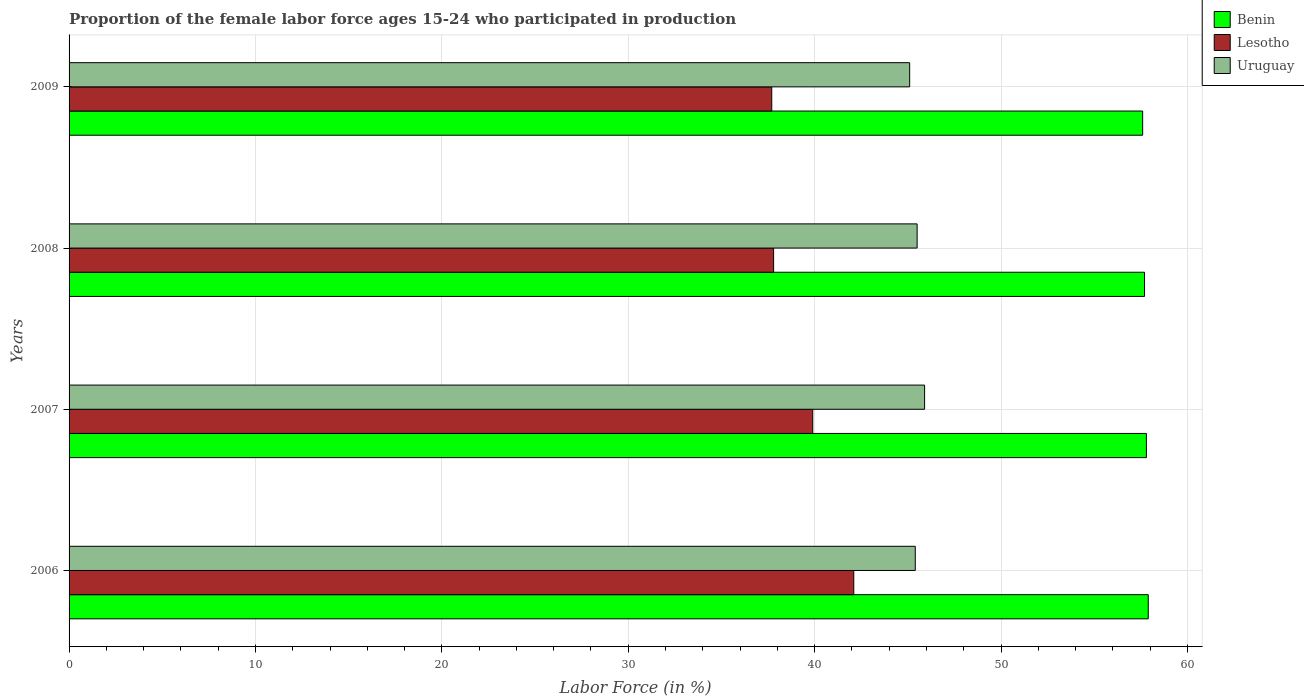How many different coloured bars are there?
Give a very brief answer. 3. How many groups of bars are there?
Ensure brevity in your answer.  4. Are the number of bars on each tick of the Y-axis equal?
Make the answer very short. Yes. What is the label of the 1st group of bars from the top?
Offer a terse response. 2009. In how many cases, is the number of bars for a given year not equal to the number of legend labels?
Offer a very short reply. 0. What is the proportion of the female labor force who participated in production in Uruguay in 2006?
Offer a very short reply. 45.4. Across all years, what is the maximum proportion of the female labor force who participated in production in Benin?
Your answer should be very brief. 57.9. Across all years, what is the minimum proportion of the female labor force who participated in production in Benin?
Ensure brevity in your answer.  57.6. In which year was the proportion of the female labor force who participated in production in Lesotho minimum?
Your answer should be compact. 2009. What is the total proportion of the female labor force who participated in production in Lesotho in the graph?
Offer a terse response. 157.5. What is the difference between the proportion of the female labor force who participated in production in Uruguay in 2006 and that in 2008?
Offer a terse response. -0.1. What is the difference between the proportion of the female labor force who participated in production in Lesotho in 2006 and the proportion of the female labor force who participated in production in Benin in 2007?
Offer a terse response. -15.7. What is the average proportion of the female labor force who participated in production in Lesotho per year?
Offer a terse response. 39.38. In the year 2007, what is the difference between the proportion of the female labor force who participated in production in Benin and proportion of the female labor force who participated in production in Uruguay?
Ensure brevity in your answer.  11.9. What is the ratio of the proportion of the female labor force who participated in production in Uruguay in 2007 to that in 2008?
Make the answer very short. 1.01. What is the difference between the highest and the second highest proportion of the female labor force who participated in production in Uruguay?
Give a very brief answer. 0.4. What is the difference between the highest and the lowest proportion of the female labor force who participated in production in Benin?
Ensure brevity in your answer.  0.3. Is the sum of the proportion of the female labor force who participated in production in Lesotho in 2006 and 2007 greater than the maximum proportion of the female labor force who participated in production in Benin across all years?
Provide a succinct answer. Yes. What does the 1st bar from the top in 2006 represents?
Offer a terse response. Uruguay. What does the 1st bar from the bottom in 2007 represents?
Ensure brevity in your answer.  Benin. How many bars are there?
Keep it short and to the point. 12. How many years are there in the graph?
Make the answer very short. 4. What is the difference between two consecutive major ticks on the X-axis?
Offer a very short reply. 10. Are the values on the major ticks of X-axis written in scientific E-notation?
Your answer should be very brief. No. Does the graph contain any zero values?
Your response must be concise. No. Does the graph contain grids?
Your answer should be very brief. Yes. Where does the legend appear in the graph?
Your answer should be compact. Top right. How many legend labels are there?
Provide a succinct answer. 3. What is the title of the graph?
Provide a succinct answer. Proportion of the female labor force ages 15-24 who participated in production. What is the label or title of the X-axis?
Give a very brief answer. Labor Force (in %). What is the label or title of the Y-axis?
Provide a short and direct response. Years. What is the Labor Force (in %) of Benin in 2006?
Provide a succinct answer. 57.9. What is the Labor Force (in %) of Lesotho in 2006?
Provide a succinct answer. 42.1. What is the Labor Force (in %) of Uruguay in 2006?
Your answer should be very brief. 45.4. What is the Labor Force (in %) of Benin in 2007?
Offer a terse response. 57.8. What is the Labor Force (in %) of Lesotho in 2007?
Keep it short and to the point. 39.9. What is the Labor Force (in %) in Uruguay in 2007?
Your response must be concise. 45.9. What is the Labor Force (in %) in Benin in 2008?
Keep it short and to the point. 57.7. What is the Labor Force (in %) in Lesotho in 2008?
Offer a very short reply. 37.8. What is the Labor Force (in %) of Uruguay in 2008?
Offer a terse response. 45.5. What is the Labor Force (in %) of Benin in 2009?
Your answer should be very brief. 57.6. What is the Labor Force (in %) in Lesotho in 2009?
Provide a short and direct response. 37.7. What is the Labor Force (in %) in Uruguay in 2009?
Provide a short and direct response. 45.1. Across all years, what is the maximum Labor Force (in %) of Benin?
Make the answer very short. 57.9. Across all years, what is the maximum Labor Force (in %) in Lesotho?
Your response must be concise. 42.1. Across all years, what is the maximum Labor Force (in %) of Uruguay?
Provide a short and direct response. 45.9. Across all years, what is the minimum Labor Force (in %) in Benin?
Your answer should be compact. 57.6. Across all years, what is the minimum Labor Force (in %) of Lesotho?
Ensure brevity in your answer.  37.7. Across all years, what is the minimum Labor Force (in %) in Uruguay?
Make the answer very short. 45.1. What is the total Labor Force (in %) in Benin in the graph?
Your answer should be very brief. 231. What is the total Labor Force (in %) in Lesotho in the graph?
Offer a terse response. 157.5. What is the total Labor Force (in %) of Uruguay in the graph?
Your answer should be very brief. 181.9. What is the difference between the Labor Force (in %) in Benin in 2006 and that in 2007?
Keep it short and to the point. 0.1. What is the difference between the Labor Force (in %) of Lesotho in 2006 and that in 2008?
Your answer should be compact. 4.3. What is the difference between the Labor Force (in %) in Uruguay in 2006 and that in 2008?
Keep it short and to the point. -0.1. What is the difference between the Labor Force (in %) of Benin in 2006 and that in 2009?
Provide a short and direct response. 0.3. What is the difference between the Labor Force (in %) of Benin in 2007 and that in 2008?
Provide a short and direct response. 0.1. What is the difference between the Labor Force (in %) of Uruguay in 2007 and that in 2008?
Your response must be concise. 0.4. What is the difference between the Labor Force (in %) of Benin in 2007 and that in 2009?
Offer a very short reply. 0.2. What is the difference between the Labor Force (in %) of Lesotho in 2007 and that in 2009?
Offer a terse response. 2.2. What is the difference between the Labor Force (in %) of Uruguay in 2007 and that in 2009?
Ensure brevity in your answer.  0.8. What is the difference between the Labor Force (in %) of Benin in 2008 and that in 2009?
Give a very brief answer. 0.1. What is the difference between the Labor Force (in %) in Benin in 2006 and the Labor Force (in %) in Lesotho in 2007?
Offer a terse response. 18. What is the difference between the Labor Force (in %) in Benin in 2006 and the Labor Force (in %) in Uruguay in 2007?
Your answer should be very brief. 12. What is the difference between the Labor Force (in %) in Lesotho in 2006 and the Labor Force (in %) in Uruguay in 2007?
Provide a succinct answer. -3.8. What is the difference between the Labor Force (in %) in Benin in 2006 and the Labor Force (in %) in Lesotho in 2008?
Offer a terse response. 20.1. What is the difference between the Labor Force (in %) in Benin in 2006 and the Labor Force (in %) in Uruguay in 2008?
Make the answer very short. 12.4. What is the difference between the Labor Force (in %) of Benin in 2006 and the Labor Force (in %) of Lesotho in 2009?
Provide a succinct answer. 20.2. What is the difference between the Labor Force (in %) of Benin in 2007 and the Labor Force (in %) of Lesotho in 2008?
Provide a short and direct response. 20. What is the difference between the Labor Force (in %) in Benin in 2007 and the Labor Force (in %) in Lesotho in 2009?
Your response must be concise. 20.1. What is the average Labor Force (in %) in Benin per year?
Make the answer very short. 57.75. What is the average Labor Force (in %) of Lesotho per year?
Provide a succinct answer. 39.38. What is the average Labor Force (in %) of Uruguay per year?
Your response must be concise. 45.48. In the year 2006, what is the difference between the Labor Force (in %) of Benin and Labor Force (in %) of Lesotho?
Give a very brief answer. 15.8. In the year 2007, what is the difference between the Labor Force (in %) in Benin and Labor Force (in %) in Lesotho?
Ensure brevity in your answer.  17.9. In the year 2007, what is the difference between the Labor Force (in %) in Benin and Labor Force (in %) in Uruguay?
Ensure brevity in your answer.  11.9. In the year 2008, what is the difference between the Labor Force (in %) of Benin and Labor Force (in %) of Uruguay?
Offer a very short reply. 12.2. In the year 2008, what is the difference between the Labor Force (in %) of Lesotho and Labor Force (in %) of Uruguay?
Offer a very short reply. -7.7. In the year 2009, what is the difference between the Labor Force (in %) of Benin and Labor Force (in %) of Lesotho?
Offer a terse response. 19.9. In the year 2009, what is the difference between the Labor Force (in %) of Benin and Labor Force (in %) of Uruguay?
Offer a very short reply. 12.5. In the year 2009, what is the difference between the Labor Force (in %) of Lesotho and Labor Force (in %) of Uruguay?
Keep it short and to the point. -7.4. What is the ratio of the Labor Force (in %) in Lesotho in 2006 to that in 2007?
Keep it short and to the point. 1.06. What is the ratio of the Labor Force (in %) of Uruguay in 2006 to that in 2007?
Provide a short and direct response. 0.99. What is the ratio of the Labor Force (in %) of Lesotho in 2006 to that in 2008?
Your response must be concise. 1.11. What is the ratio of the Labor Force (in %) in Uruguay in 2006 to that in 2008?
Your answer should be very brief. 1. What is the ratio of the Labor Force (in %) in Lesotho in 2006 to that in 2009?
Provide a succinct answer. 1.12. What is the ratio of the Labor Force (in %) in Uruguay in 2006 to that in 2009?
Your answer should be very brief. 1.01. What is the ratio of the Labor Force (in %) in Lesotho in 2007 to that in 2008?
Your answer should be compact. 1.06. What is the ratio of the Labor Force (in %) of Uruguay in 2007 to that in 2008?
Your answer should be very brief. 1.01. What is the ratio of the Labor Force (in %) of Benin in 2007 to that in 2009?
Give a very brief answer. 1. What is the ratio of the Labor Force (in %) of Lesotho in 2007 to that in 2009?
Your response must be concise. 1.06. What is the ratio of the Labor Force (in %) in Uruguay in 2007 to that in 2009?
Your response must be concise. 1.02. What is the ratio of the Labor Force (in %) of Lesotho in 2008 to that in 2009?
Keep it short and to the point. 1. What is the ratio of the Labor Force (in %) in Uruguay in 2008 to that in 2009?
Keep it short and to the point. 1.01. What is the difference between the highest and the second highest Labor Force (in %) of Benin?
Offer a very short reply. 0.1. What is the difference between the highest and the second highest Labor Force (in %) in Lesotho?
Give a very brief answer. 2.2. What is the difference between the highest and the second highest Labor Force (in %) of Uruguay?
Your answer should be compact. 0.4. 